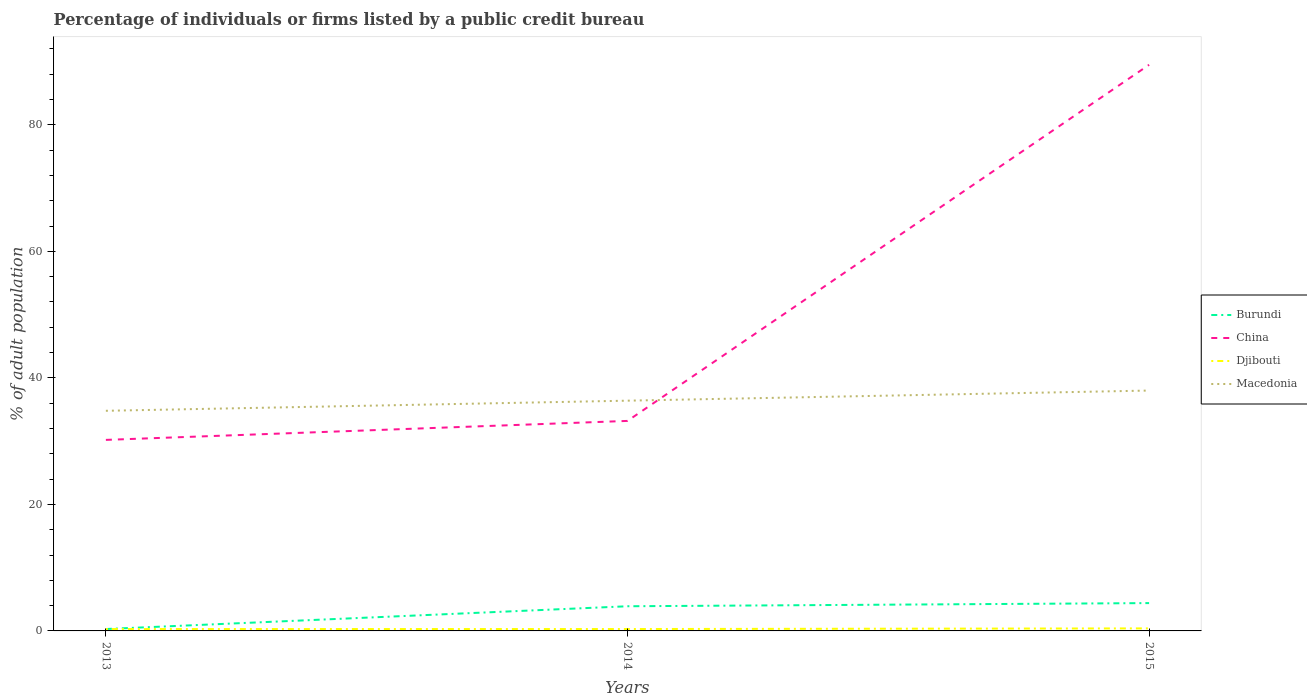Does the line corresponding to Burundi intersect with the line corresponding to Djibouti?
Your response must be concise. Yes. Is the number of lines equal to the number of legend labels?
Your response must be concise. Yes. In which year was the percentage of population listed by a public credit bureau in Burundi maximum?
Your answer should be very brief. 2013. What is the total percentage of population listed by a public credit bureau in Djibouti in the graph?
Keep it short and to the point. -0.1. What is the difference between the highest and the second highest percentage of population listed by a public credit bureau in Macedonia?
Keep it short and to the point. 3.2. How many lines are there?
Ensure brevity in your answer.  4. How many years are there in the graph?
Your answer should be very brief. 3. What is the difference between two consecutive major ticks on the Y-axis?
Give a very brief answer. 20. Are the values on the major ticks of Y-axis written in scientific E-notation?
Provide a succinct answer. No. Does the graph contain any zero values?
Keep it short and to the point. No. What is the title of the graph?
Keep it short and to the point. Percentage of individuals or firms listed by a public credit bureau. What is the label or title of the X-axis?
Give a very brief answer. Years. What is the label or title of the Y-axis?
Your response must be concise. % of adult population. What is the % of adult population in Burundi in 2013?
Your answer should be very brief. 0.3. What is the % of adult population in China in 2013?
Make the answer very short. 30.2. What is the % of adult population in Djibouti in 2013?
Ensure brevity in your answer.  0.3. What is the % of adult population of Macedonia in 2013?
Offer a very short reply. 34.8. What is the % of adult population of Burundi in 2014?
Ensure brevity in your answer.  3.9. What is the % of adult population in China in 2014?
Ensure brevity in your answer.  33.2. What is the % of adult population of Djibouti in 2014?
Make the answer very short. 0.3. What is the % of adult population in Macedonia in 2014?
Ensure brevity in your answer.  36.4. What is the % of adult population of China in 2015?
Your answer should be very brief. 89.5. What is the % of adult population in Djibouti in 2015?
Keep it short and to the point. 0.4. Across all years, what is the maximum % of adult population of China?
Offer a very short reply. 89.5. Across all years, what is the maximum % of adult population of Macedonia?
Provide a short and direct response. 38. Across all years, what is the minimum % of adult population of China?
Provide a succinct answer. 30.2. Across all years, what is the minimum % of adult population in Djibouti?
Provide a succinct answer. 0.3. Across all years, what is the minimum % of adult population in Macedonia?
Offer a terse response. 34.8. What is the total % of adult population of Burundi in the graph?
Give a very brief answer. 8.6. What is the total % of adult population of China in the graph?
Keep it short and to the point. 152.9. What is the total % of adult population of Djibouti in the graph?
Provide a succinct answer. 1. What is the total % of adult population in Macedonia in the graph?
Provide a short and direct response. 109.2. What is the difference between the % of adult population of Burundi in 2013 and that in 2014?
Offer a terse response. -3.6. What is the difference between the % of adult population in Djibouti in 2013 and that in 2014?
Your answer should be very brief. 0. What is the difference between the % of adult population of Burundi in 2013 and that in 2015?
Provide a succinct answer. -4.1. What is the difference between the % of adult population in China in 2013 and that in 2015?
Your response must be concise. -59.3. What is the difference between the % of adult population in China in 2014 and that in 2015?
Keep it short and to the point. -56.3. What is the difference between the % of adult population of Djibouti in 2014 and that in 2015?
Provide a succinct answer. -0.1. What is the difference between the % of adult population of Burundi in 2013 and the % of adult population of China in 2014?
Offer a very short reply. -32.9. What is the difference between the % of adult population of Burundi in 2013 and the % of adult population of Djibouti in 2014?
Your answer should be compact. 0. What is the difference between the % of adult population in Burundi in 2013 and the % of adult population in Macedonia in 2014?
Offer a very short reply. -36.1. What is the difference between the % of adult population of China in 2013 and the % of adult population of Djibouti in 2014?
Your answer should be compact. 29.9. What is the difference between the % of adult population in Djibouti in 2013 and the % of adult population in Macedonia in 2014?
Ensure brevity in your answer.  -36.1. What is the difference between the % of adult population of Burundi in 2013 and the % of adult population of China in 2015?
Your response must be concise. -89.2. What is the difference between the % of adult population in Burundi in 2013 and the % of adult population in Macedonia in 2015?
Your response must be concise. -37.7. What is the difference between the % of adult population in China in 2013 and the % of adult population in Djibouti in 2015?
Give a very brief answer. 29.8. What is the difference between the % of adult population of China in 2013 and the % of adult population of Macedonia in 2015?
Make the answer very short. -7.8. What is the difference between the % of adult population in Djibouti in 2013 and the % of adult population in Macedonia in 2015?
Keep it short and to the point. -37.7. What is the difference between the % of adult population of Burundi in 2014 and the % of adult population of China in 2015?
Ensure brevity in your answer.  -85.6. What is the difference between the % of adult population in Burundi in 2014 and the % of adult population in Macedonia in 2015?
Your answer should be compact. -34.1. What is the difference between the % of adult population in China in 2014 and the % of adult population in Djibouti in 2015?
Your response must be concise. 32.8. What is the difference between the % of adult population of China in 2014 and the % of adult population of Macedonia in 2015?
Your response must be concise. -4.8. What is the difference between the % of adult population in Djibouti in 2014 and the % of adult population in Macedonia in 2015?
Offer a very short reply. -37.7. What is the average % of adult population in Burundi per year?
Provide a short and direct response. 2.87. What is the average % of adult population in China per year?
Offer a very short reply. 50.97. What is the average % of adult population of Djibouti per year?
Your answer should be very brief. 0.33. What is the average % of adult population in Macedonia per year?
Make the answer very short. 36.4. In the year 2013, what is the difference between the % of adult population of Burundi and % of adult population of China?
Your response must be concise. -29.9. In the year 2013, what is the difference between the % of adult population of Burundi and % of adult population of Macedonia?
Your answer should be compact. -34.5. In the year 2013, what is the difference between the % of adult population in China and % of adult population in Djibouti?
Offer a terse response. 29.9. In the year 2013, what is the difference between the % of adult population in China and % of adult population in Macedonia?
Offer a terse response. -4.6. In the year 2013, what is the difference between the % of adult population in Djibouti and % of adult population in Macedonia?
Give a very brief answer. -34.5. In the year 2014, what is the difference between the % of adult population in Burundi and % of adult population in China?
Your answer should be compact. -29.3. In the year 2014, what is the difference between the % of adult population of Burundi and % of adult population of Djibouti?
Your response must be concise. 3.6. In the year 2014, what is the difference between the % of adult population in Burundi and % of adult population in Macedonia?
Make the answer very short. -32.5. In the year 2014, what is the difference between the % of adult population in China and % of adult population in Djibouti?
Your response must be concise. 32.9. In the year 2014, what is the difference between the % of adult population in China and % of adult population in Macedonia?
Ensure brevity in your answer.  -3.2. In the year 2014, what is the difference between the % of adult population in Djibouti and % of adult population in Macedonia?
Make the answer very short. -36.1. In the year 2015, what is the difference between the % of adult population in Burundi and % of adult population in China?
Provide a short and direct response. -85.1. In the year 2015, what is the difference between the % of adult population in Burundi and % of adult population in Macedonia?
Make the answer very short. -33.6. In the year 2015, what is the difference between the % of adult population of China and % of adult population of Djibouti?
Ensure brevity in your answer.  89.1. In the year 2015, what is the difference between the % of adult population of China and % of adult population of Macedonia?
Provide a short and direct response. 51.5. In the year 2015, what is the difference between the % of adult population in Djibouti and % of adult population in Macedonia?
Your answer should be very brief. -37.6. What is the ratio of the % of adult population of Burundi in 2013 to that in 2014?
Your response must be concise. 0.08. What is the ratio of the % of adult population of China in 2013 to that in 2014?
Your answer should be very brief. 0.91. What is the ratio of the % of adult population in Macedonia in 2013 to that in 2014?
Offer a very short reply. 0.96. What is the ratio of the % of adult population in Burundi in 2013 to that in 2015?
Provide a succinct answer. 0.07. What is the ratio of the % of adult population in China in 2013 to that in 2015?
Your answer should be compact. 0.34. What is the ratio of the % of adult population of Macedonia in 2013 to that in 2015?
Make the answer very short. 0.92. What is the ratio of the % of adult population of Burundi in 2014 to that in 2015?
Make the answer very short. 0.89. What is the ratio of the % of adult population in China in 2014 to that in 2015?
Your response must be concise. 0.37. What is the ratio of the % of adult population of Djibouti in 2014 to that in 2015?
Offer a very short reply. 0.75. What is the ratio of the % of adult population of Macedonia in 2014 to that in 2015?
Ensure brevity in your answer.  0.96. What is the difference between the highest and the second highest % of adult population of Burundi?
Ensure brevity in your answer.  0.5. What is the difference between the highest and the second highest % of adult population in China?
Provide a short and direct response. 56.3. What is the difference between the highest and the second highest % of adult population of Macedonia?
Ensure brevity in your answer.  1.6. What is the difference between the highest and the lowest % of adult population in Burundi?
Provide a short and direct response. 4.1. What is the difference between the highest and the lowest % of adult population of China?
Provide a succinct answer. 59.3. What is the difference between the highest and the lowest % of adult population in Djibouti?
Provide a succinct answer. 0.1. 